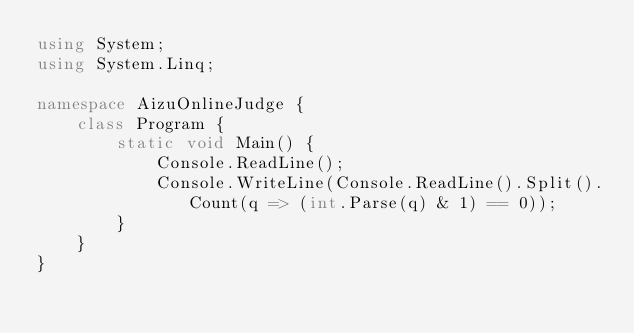<code> <loc_0><loc_0><loc_500><loc_500><_C#_>using System;
using System.Linq;

namespace AizuOnlineJudge {
    class Program {
        static void Main() {
            Console.ReadLine();
            Console.WriteLine(Console.ReadLine().Split().Count(q => (int.Parse(q) & 1) == 0));
        }
    }
}

</code> 